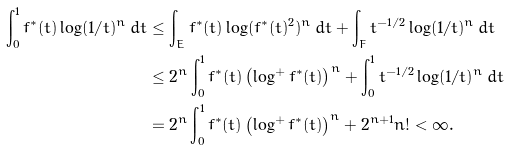Convert formula to latex. <formula><loc_0><loc_0><loc_500><loc_500>\int _ { 0 } ^ { 1 } f ^ { * } ( t ) \log ( 1 / t ) ^ { n } \, d t & \leq \int _ { E } f ^ { * } ( t ) \log ( f ^ { * } ( t ) ^ { 2 } ) ^ { n } \, d t + \int _ { F } t ^ { - 1 / 2 } \log ( 1 / t ) ^ { n } \, d t \\ & \leq 2 ^ { n } \int _ { 0 } ^ { 1 } f ^ { * } ( t ) \left ( \log ^ { + } f ^ { * } ( t ) \right ) ^ { n } + \int _ { 0 } ^ { 1 } t ^ { - 1 / 2 } \log ( 1 / t ) ^ { n } \, d t \\ & = 2 ^ { n } \int _ { 0 } ^ { 1 } f ^ { * } ( t ) \left ( \log ^ { + } f ^ { * } ( t ) \right ) ^ { n } + 2 ^ { n + 1 } n ! < \infty .</formula> 